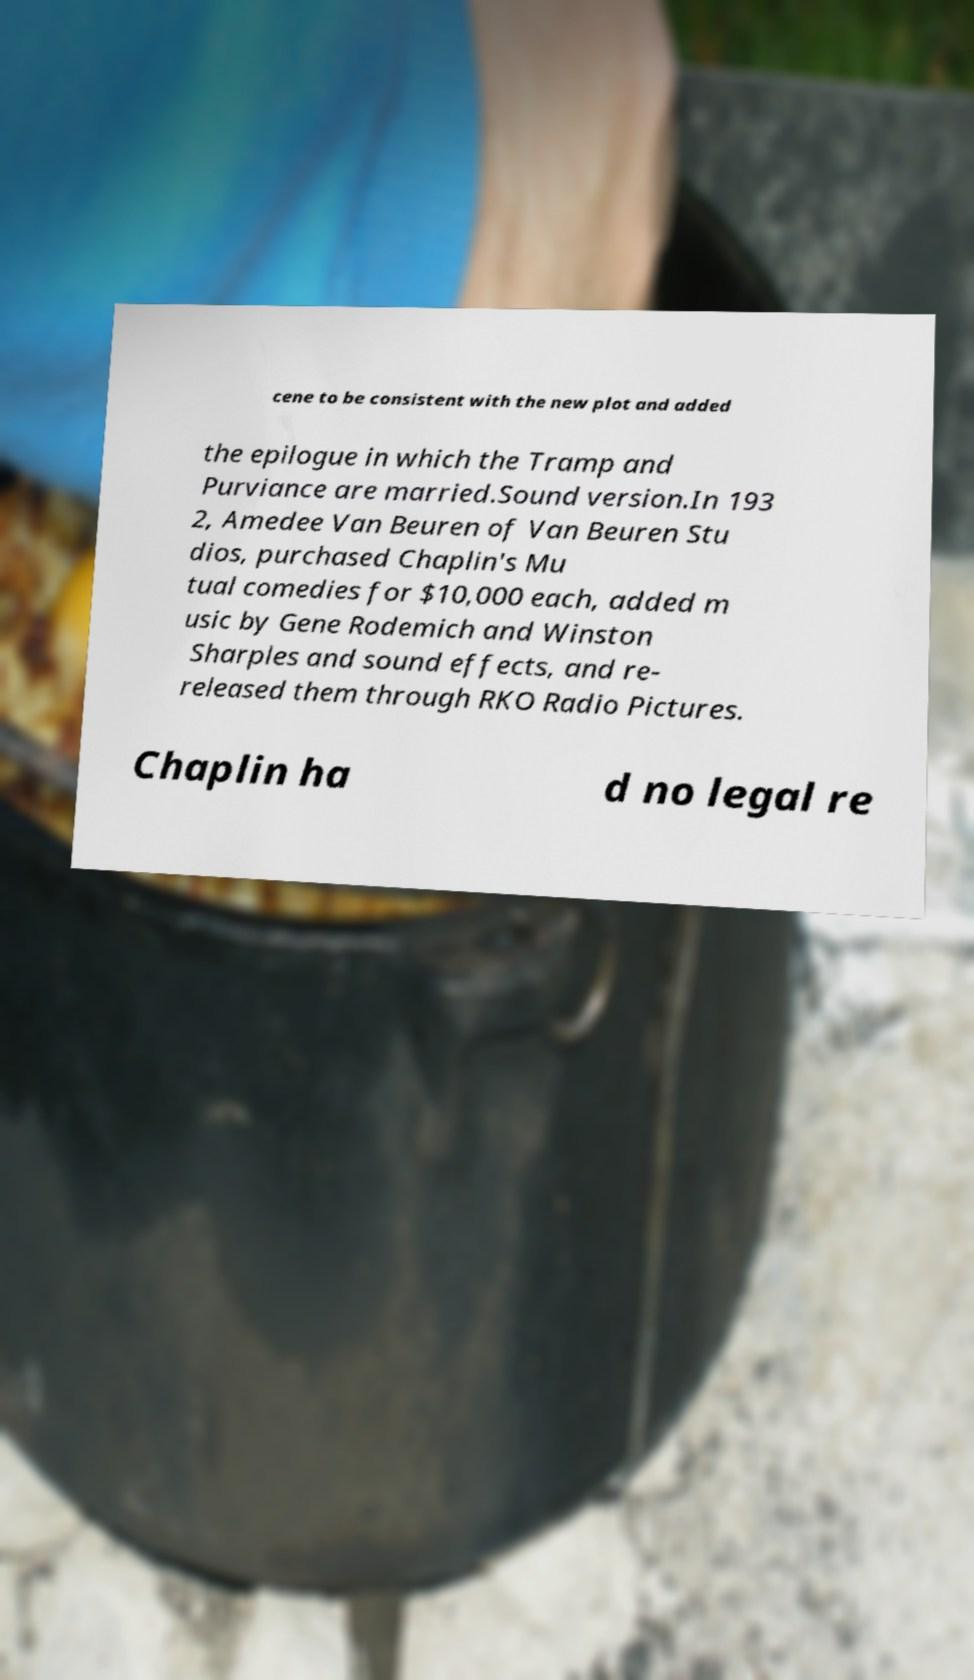I need the written content from this picture converted into text. Can you do that? cene to be consistent with the new plot and added the epilogue in which the Tramp and Purviance are married.Sound version.In 193 2, Amedee Van Beuren of Van Beuren Stu dios, purchased Chaplin's Mu tual comedies for $10,000 each, added m usic by Gene Rodemich and Winston Sharples and sound effects, and re- released them through RKO Radio Pictures. Chaplin ha d no legal re 